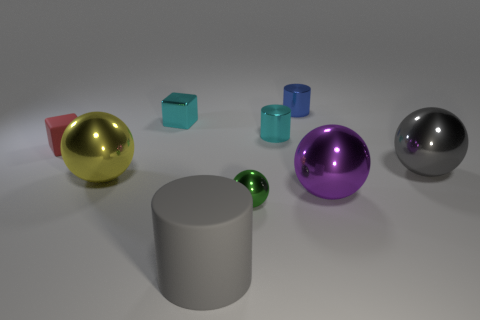Subtract all big spheres. How many spheres are left? 1 Subtract all yellow spheres. How many spheres are left? 3 Subtract all cubes. How many objects are left? 7 Add 2 red things. How many red things are left? 3 Add 6 small gray rubber cubes. How many small gray rubber cubes exist? 6 Subtract 0 red cylinders. How many objects are left? 9 Subtract 3 spheres. How many spheres are left? 1 Subtract all cyan cylinders. Subtract all brown spheres. How many cylinders are left? 2 Subtract all blue cylinders. How many brown blocks are left? 0 Subtract all tiny yellow rubber things. Subtract all gray cylinders. How many objects are left? 8 